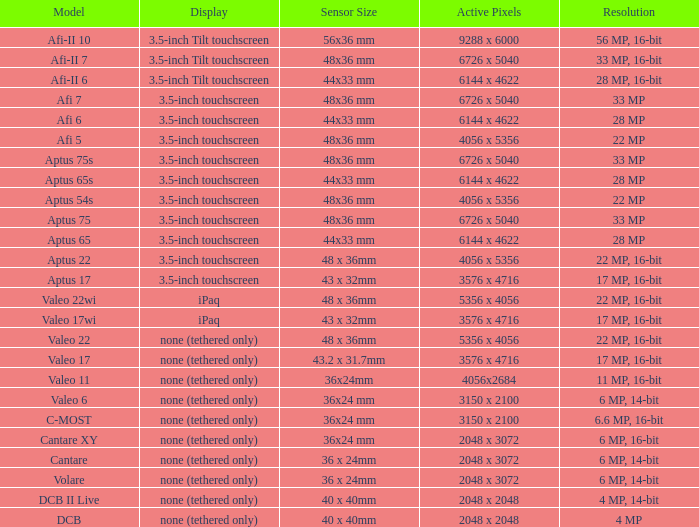What are the active pixels of the c-most model camera? 3150 x 2100. 